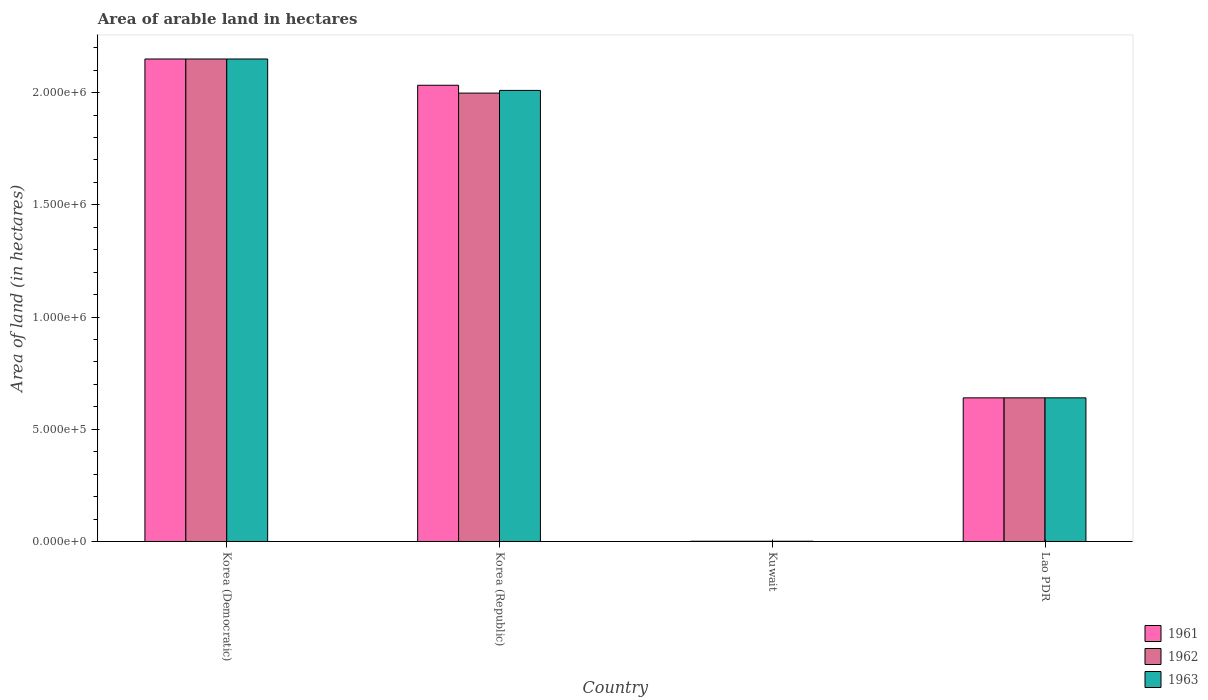How many different coloured bars are there?
Ensure brevity in your answer.  3. Are the number of bars per tick equal to the number of legend labels?
Your answer should be very brief. Yes. Are the number of bars on each tick of the X-axis equal?
Keep it short and to the point. Yes. What is the total arable land in 1962 in Lao PDR?
Offer a terse response. 6.40e+05. Across all countries, what is the maximum total arable land in 1962?
Give a very brief answer. 2.15e+06. Across all countries, what is the minimum total arable land in 1962?
Make the answer very short. 1000. In which country was the total arable land in 1963 maximum?
Offer a very short reply. Korea (Democratic). In which country was the total arable land in 1961 minimum?
Your answer should be very brief. Kuwait. What is the total total arable land in 1963 in the graph?
Provide a short and direct response. 4.80e+06. What is the difference between the total arable land in 1962 in Korea (Democratic) and that in Korea (Republic)?
Offer a terse response. 1.52e+05. What is the difference between the total arable land in 1962 in Korea (Republic) and the total arable land in 1963 in Lao PDR?
Provide a short and direct response. 1.36e+06. What is the average total arable land in 1963 per country?
Provide a short and direct response. 1.20e+06. What is the ratio of the total arable land in 1961 in Korea (Republic) to that in Kuwait?
Provide a succinct answer. 2033. Is the total arable land in 1963 in Korea (Democratic) less than that in Lao PDR?
Provide a succinct answer. No. What is the difference between the highest and the second highest total arable land in 1963?
Offer a very short reply. 1.51e+06. What is the difference between the highest and the lowest total arable land in 1963?
Keep it short and to the point. 2.15e+06. In how many countries, is the total arable land in 1962 greater than the average total arable land in 1962 taken over all countries?
Your answer should be compact. 2. Is the sum of the total arable land in 1963 in Korea (Republic) and Lao PDR greater than the maximum total arable land in 1962 across all countries?
Make the answer very short. Yes. What does the 1st bar from the left in Lao PDR represents?
Your answer should be compact. 1961. How many countries are there in the graph?
Make the answer very short. 4. What is the difference between two consecutive major ticks on the Y-axis?
Ensure brevity in your answer.  5.00e+05. Does the graph contain any zero values?
Give a very brief answer. No. Where does the legend appear in the graph?
Provide a short and direct response. Bottom right. How many legend labels are there?
Offer a very short reply. 3. What is the title of the graph?
Your response must be concise. Area of arable land in hectares. What is the label or title of the Y-axis?
Provide a short and direct response. Area of land (in hectares). What is the Area of land (in hectares) in 1961 in Korea (Democratic)?
Ensure brevity in your answer.  2.15e+06. What is the Area of land (in hectares) of 1962 in Korea (Democratic)?
Give a very brief answer. 2.15e+06. What is the Area of land (in hectares) in 1963 in Korea (Democratic)?
Make the answer very short. 2.15e+06. What is the Area of land (in hectares) in 1961 in Korea (Republic)?
Your response must be concise. 2.03e+06. What is the Area of land (in hectares) of 1962 in Korea (Republic)?
Provide a succinct answer. 2.00e+06. What is the Area of land (in hectares) in 1963 in Korea (Republic)?
Ensure brevity in your answer.  2.01e+06. What is the Area of land (in hectares) in 1963 in Kuwait?
Provide a short and direct response. 1000. What is the Area of land (in hectares) of 1961 in Lao PDR?
Provide a short and direct response. 6.40e+05. What is the Area of land (in hectares) in 1962 in Lao PDR?
Provide a succinct answer. 6.40e+05. What is the Area of land (in hectares) of 1963 in Lao PDR?
Provide a short and direct response. 6.40e+05. Across all countries, what is the maximum Area of land (in hectares) in 1961?
Give a very brief answer. 2.15e+06. Across all countries, what is the maximum Area of land (in hectares) in 1962?
Offer a very short reply. 2.15e+06. Across all countries, what is the maximum Area of land (in hectares) in 1963?
Keep it short and to the point. 2.15e+06. Across all countries, what is the minimum Area of land (in hectares) of 1961?
Your answer should be very brief. 1000. What is the total Area of land (in hectares) of 1961 in the graph?
Provide a short and direct response. 4.82e+06. What is the total Area of land (in hectares) in 1962 in the graph?
Offer a terse response. 4.79e+06. What is the total Area of land (in hectares) in 1963 in the graph?
Offer a terse response. 4.80e+06. What is the difference between the Area of land (in hectares) of 1961 in Korea (Democratic) and that in Korea (Republic)?
Give a very brief answer. 1.17e+05. What is the difference between the Area of land (in hectares) of 1962 in Korea (Democratic) and that in Korea (Republic)?
Make the answer very short. 1.52e+05. What is the difference between the Area of land (in hectares) of 1963 in Korea (Democratic) and that in Korea (Republic)?
Give a very brief answer. 1.40e+05. What is the difference between the Area of land (in hectares) of 1961 in Korea (Democratic) and that in Kuwait?
Your answer should be compact. 2.15e+06. What is the difference between the Area of land (in hectares) of 1962 in Korea (Democratic) and that in Kuwait?
Your response must be concise. 2.15e+06. What is the difference between the Area of land (in hectares) in 1963 in Korea (Democratic) and that in Kuwait?
Give a very brief answer. 2.15e+06. What is the difference between the Area of land (in hectares) of 1961 in Korea (Democratic) and that in Lao PDR?
Provide a succinct answer. 1.51e+06. What is the difference between the Area of land (in hectares) in 1962 in Korea (Democratic) and that in Lao PDR?
Ensure brevity in your answer.  1.51e+06. What is the difference between the Area of land (in hectares) in 1963 in Korea (Democratic) and that in Lao PDR?
Your response must be concise. 1.51e+06. What is the difference between the Area of land (in hectares) in 1961 in Korea (Republic) and that in Kuwait?
Offer a very short reply. 2.03e+06. What is the difference between the Area of land (in hectares) of 1962 in Korea (Republic) and that in Kuwait?
Your answer should be compact. 2.00e+06. What is the difference between the Area of land (in hectares) in 1963 in Korea (Republic) and that in Kuwait?
Give a very brief answer. 2.01e+06. What is the difference between the Area of land (in hectares) in 1961 in Korea (Republic) and that in Lao PDR?
Your answer should be compact. 1.39e+06. What is the difference between the Area of land (in hectares) of 1962 in Korea (Republic) and that in Lao PDR?
Ensure brevity in your answer.  1.36e+06. What is the difference between the Area of land (in hectares) in 1963 in Korea (Republic) and that in Lao PDR?
Give a very brief answer. 1.37e+06. What is the difference between the Area of land (in hectares) of 1961 in Kuwait and that in Lao PDR?
Provide a succinct answer. -6.39e+05. What is the difference between the Area of land (in hectares) in 1962 in Kuwait and that in Lao PDR?
Offer a very short reply. -6.39e+05. What is the difference between the Area of land (in hectares) of 1963 in Kuwait and that in Lao PDR?
Give a very brief answer. -6.39e+05. What is the difference between the Area of land (in hectares) of 1961 in Korea (Democratic) and the Area of land (in hectares) of 1962 in Korea (Republic)?
Your answer should be very brief. 1.52e+05. What is the difference between the Area of land (in hectares) of 1961 in Korea (Democratic) and the Area of land (in hectares) of 1963 in Korea (Republic)?
Provide a succinct answer. 1.40e+05. What is the difference between the Area of land (in hectares) of 1962 in Korea (Democratic) and the Area of land (in hectares) of 1963 in Korea (Republic)?
Your answer should be very brief. 1.40e+05. What is the difference between the Area of land (in hectares) in 1961 in Korea (Democratic) and the Area of land (in hectares) in 1962 in Kuwait?
Your response must be concise. 2.15e+06. What is the difference between the Area of land (in hectares) of 1961 in Korea (Democratic) and the Area of land (in hectares) of 1963 in Kuwait?
Your answer should be compact. 2.15e+06. What is the difference between the Area of land (in hectares) in 1962 in Korea (Democratic) and the Area of land (in hectares) in 1963 in Kuwait?
Provide a short and direct response. 2.15e+06. What is the difference between the Area of land (in hectares) in 1961 in Korea (Democratic) and the Area of land (in hectares) in 1962 in Lao PDR?
Your answer should be compact. 1.51e+06. What is the difference between the Area of land (in hectares) of 1961 in Korea (Democratic) and the Area of land (in hectares) of 1963 in Lao PDR?
Make the answer very short. 1.51e+06. What is the difference between the Area of land (in hectares) of 1962 in Korea (Democratic) and the Area of land (in hectares) of 1963 in Lao PDR?
Offer a terse response. 1.51e+06. What is the difference between the Area of land (in hectares) of 1961 in Korea (Republic) and the Area of land (in hectares) of 1962 in Kuwait?
Your answer should be compact. 2.03e+06. What is the difference between the Area of land (in hectares) of 1961 in Korea (Republic) and the Area of land (in hectares) of 1963 in Kuwait?
Give a very brief answer. 2.03e+06. What is the difference between the Area of land (in hectares) in 1962 in Korea (Republic) and the Area of land (in hectares) in 1963 in Kuwait?
Ensure brevity in your answer.  2.00e+06. What is the difference between the Area of land (in hectares) in 1961 in Korea (Republic) and the Area of land (in hectares) in 1962 in Lao PDR?
Your answer should be very brief. 1.39e+06. What is the difference between the Area of land (in hectares) in 1961 in Korea (Republic) and the Area of land (in hectares) in 1963 in Lao PDR?
Give a very brief answer. 1.39e+06. What is the difference between the Area of land (in hectares) of 1962 in Korea (Republic) and the Area of land (in hectares) of 1963 in Lao PDR?
Ensure brevity in your answer.  1.36e+06. What is the difference between the Area of land (in hectares) in 1961 in Kuwait and the Area of land (in hectares) in 1962 in Lao PDR?
Your answer should be very brief. -6.39e+05. What is the difference between the Area of land (in hectares) of 1961 in Kuwait and the Area of land (in hectares) of 1963 in Lao PDR?
Offer a terse response. -6.39e+05. What is the difference between the Area of land (in hectares) of 1962 in Kuwait and the Area of land (in hectares) of 1963 in Lao PDR?
Provide a short and direct response. -6.39e+05. What is the average Area of land (in hectares) of 1961 per country?
Provide a short and direct response. 1.21e+06. What is the average Area of land (in hectares) of 1962 per country?
Make the answer very short. 1.20e+06. What is the average Area of land (in hectares) in 1963 per country?
Ensure brevity in your answer.  1.20e+06. What is the difference between the Area of land (in hectares) of 1961 and Area of land (in hectares) of 1962 in Korea (Democratic)?
Your answer should be compact. 0. What is the difference between the Area of land (in hectares) in 1961 and Area of land (in hectares) in 1962 in Korea (Republic)?
Give a very brief answer. 3.50e+04. What is the difference between the Area of land (in hectares) in 1961 and Area of land (in hectares) in 1963 in Korea (Republic)?
Your answer should be compact. 2.30e+04. What is the difference between the Area of land (in hectares) in 1962 and Area of land (in hectares) in 1963 in Korea (Republic)?
Ensure brevity in your answer.  -1.20e+04. What is the difference between the Area of land (in hectares) in 1961 and Area of land (in hectares) in 1962 in Kuwait?
Your answer should be very brief. 0. What is the difference between the Area of land (in hectares) of 1962 and Area of land (in hectares) of 1963 in Kuwait?
Your answer should be compact. 0. What is the difference between the Area of land (in hectares) of 1961 and Area of land (in hectares) of 1963 in Lao PDR?
Your response must be concise. 0. What is the ratio of the Area of land (in hectares) in 1961 in Korea (Democratic) to that in Korea (Republic)?
Offer a very short reply. 1.06. What is the ratio of the Area of land (in hectares) in 1962 in Korea (Democratic) to that in Korea (Republic)?
Give a very brief answer. 1.08. What is the ratio of the Area of land (in hectares) of 1963 in Korea (Democratic) to that in Korea (Republic)?
Provide a succinct answer. 1.07. What is the ratio of the Area of land (in hectares) of 1961 in Korea (Democratic) to that in Kuwait?
Your answer should be very brief. 2150. What is the ratio of the Area of land (in hectares) in 1962 in Korea (Democratic) to that in Kuwait?
Your response must be concise. 2150. What is the ratio of the Area of land (in hectares) of 1963 in Korea (Democratic) to that in Kuwait?
Provide a succinct answer. 2150. What is the ratio of the Area of land (in hectares) in 1961 in Korea (Democratic) to that in Lao PDR?
Your answer should be very brief. 3.36. What is the ratio of the Area of land (in hectares) of 1962 in Korea (Democratic) to that in Lao PDR?
Provide a short and direct response. 3.36. What is the ratio of the Area of land (in hectares) in 1963 in Korea (Democratic) to that in Lao PDR?
Give a very brief answer. 3.36. What is the ratio of the Area of land (in hectares) of 1961 in Korea (Republic) to that in Kuwait?
Make the answer very short. 2033. What is the ratio of the Area of land (in hectares) in 1962 in Korea (Republic) to that in Kuwait?
Keep it short and to the point. 1998. What is the ratio of the Area of land (in hectares) of 1963 in Korea (Republic) to that in Kuwait?
Offer a terse response. 2010. What is the ratio of the Area of land (in hectares) of 1961 in Korea (Republic) to that in Lao PDR?
Your answer should be compact. 3.18. What is the ratio of the Area of land (in hectares) of 1962 in Korea (Republic) to that in Lao PDR?
Your answer should be compact. 3.12. What is the ratio of the Area of land (in hectares) of 1963 in Korea (Republic) to that in Lao PDR?
Ensure brevity in your answer.  3.14. What is the ratio of the Area of land (in hectares) of 1961 in Kuwait to that in Lao PDR?
Provide a succinct answer. 0. What is the ratio of the Area of land (in hectares) in 1962 in Kuwait to that in Lao PDR?
Make the answer very short. 0. What is the ratio of the Area of land (in hectares) of 1963 in Kuwait to that in Lao PDR?
Your answer should be compact. 0. What is the difference between the highest and the second highest Area of land (in hectares) of 1961?
Keep it short and to the point. 1.17e+05. What is the difference between the highest and the second highest Area of land (in hectares) in 1962?
Make the answer very short. 1.52e+05. What is the difference between the highest and the second highest Area of land (in hectares) of 1963?
Your answer should be compact. 1.40e+05. What is the difference between the highest and the lowest Area of land (in hectares) of 1961?
Provide a short and direct response. 2.15e+06. What is the difference between the highest and the lowest Area of land (in hectares) in 1962?
Your answer should be very brief. 2.15e+06. What is the difference between the highest and the lowest Area of land (in hectares) of 1963?
Your answer should be compact. 2.15e+06. 